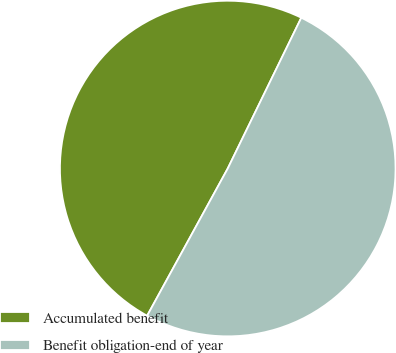Convert chart. <chart><loc_0><loc_0><loc_500><loc_500><pie_chart><fcel>Accumulated benefit<fcel>Benefit obligation-end of year<nl><fcel>49.25%<fcel>50.75%<nl></chart> 